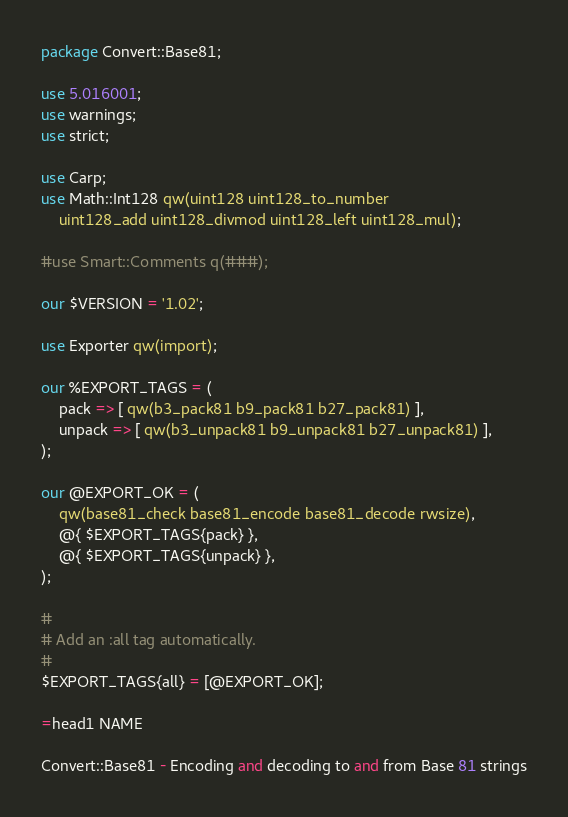<code> <loc_0><loc_0><loc_500><loc_500><_Perl_>package Convert::Base81;

use 5.016001;
use warnings;
use strict;

use Carp;
use Math::Int128 qw(uint128 uint128_to_number
	uint128_add uint128_divmod uint128_left uint128_mul);

#use Smart::Comments q(###);

our $VERSION = '1.02';

use Exporter qw(import);

our %EXPORT_TAGS = (
	pack => [ qw(b3_pack81 b9_pack81 b27_pack81) ],
	unpack => [ qw(b3_unpack81 b9_unpack81 b27_unpack81) ],
);

our @EXPORT_OK = (
	qw(base81_check base81_encode base81_decode rwsize),
	@{ $EXPORT_TAGS{pack} },
	@{ $EXPORT_TAGS{unpack} },
);

#
# Add an :all tag automatically.
#
$EXPORT_TAGS{all} = [@EXPORT_OK];

=head1 NAME

Convert::Base81 - Encoding and decoding to and from Base 81 strings
</code> 